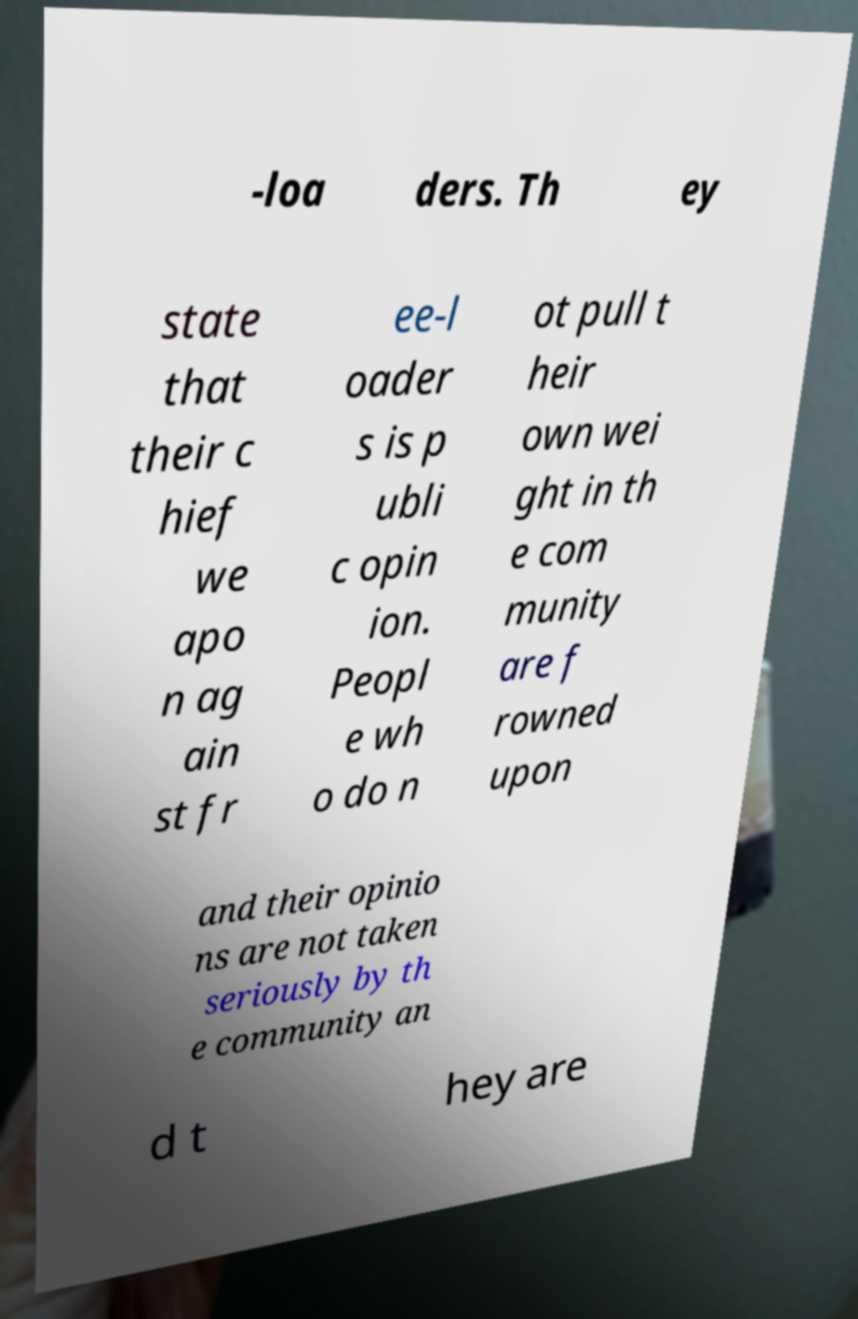Can you accurately transcribe the text from the provided image for me? -loa ders. Th ey state that their c hief we apo n ag ain st fr ee-l oader s is p ubli c opin ion. Peopl e wh o do n ot pull t heir own wei ght in th e com munity are f rowned upon and their opinio ns are not taken seriously by th e community an d t hey are 